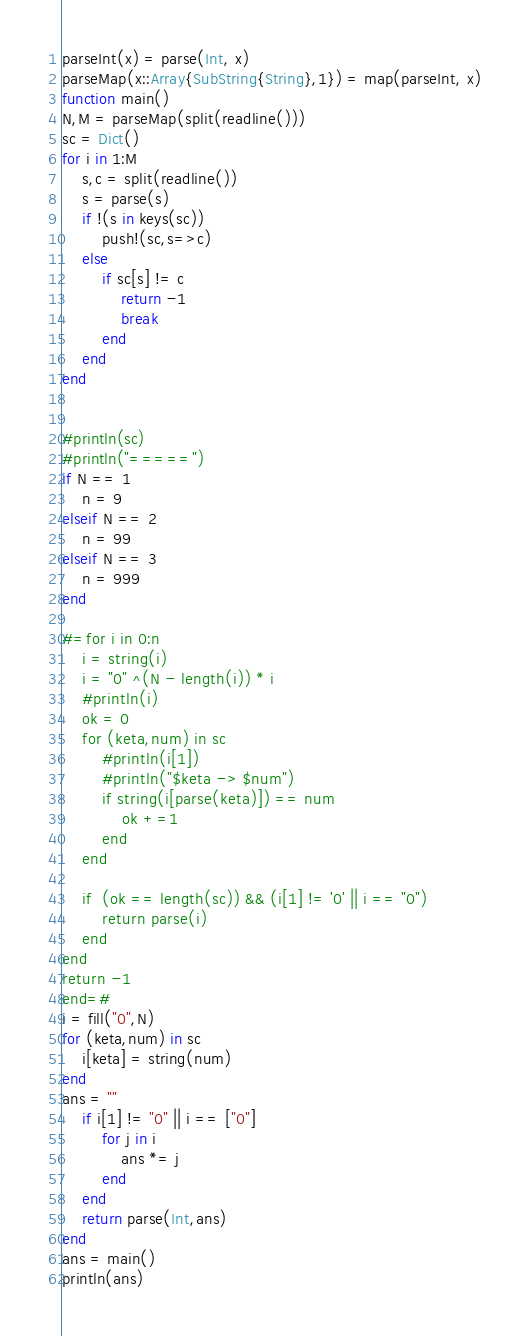Convert code to text. <code><loc_0><loc_0><loc_500><loc_500><_Julia_>parseInt(x) = parse(Int, x)
parseMap(x::Array{SubString{String},1}) = map(parseInt, x)
function main()
N,M = parseMap(split(readline()))
sc = Dict()
for i in 1:M
    s,c = split(readline())
    s = parse(s)
    if !(s in keys(sc))
        push!(sc,s=>c)
    else
        if sc[s] != c
            return -1
            break
        end
    end
end


#println(sc)
#println("=====")
if N == 1
    n = 9
elseif N == 2
    n = 99
elseif N == 3
    n = 999
end

#=for i in 0:n
    i = string(i)
    i = "0" ^(N - length(i)) * i
    #println(i)
    ok = 0
    for (keta,num) in sc
        #println(i[1])
        #println("$keta -> $num")
        if string(i[parse(keta)]) == num
            ok +=1
        end
    end

    if  (ok == length(sc)) && (i[1] != '0' || i == "0")
        return parse(i)
    end
end             
return -1   
end=#
i = fill("0",N)
for (keta,num) in sc
    i[keta] = string(num)
end
ans = ""
    if i[1] != "0" || i == ["0"]
        for j in i
            ans *= j
        end    
    end    
    return parse(Int,ans)
end
ans = main()
println(ans)</code> 